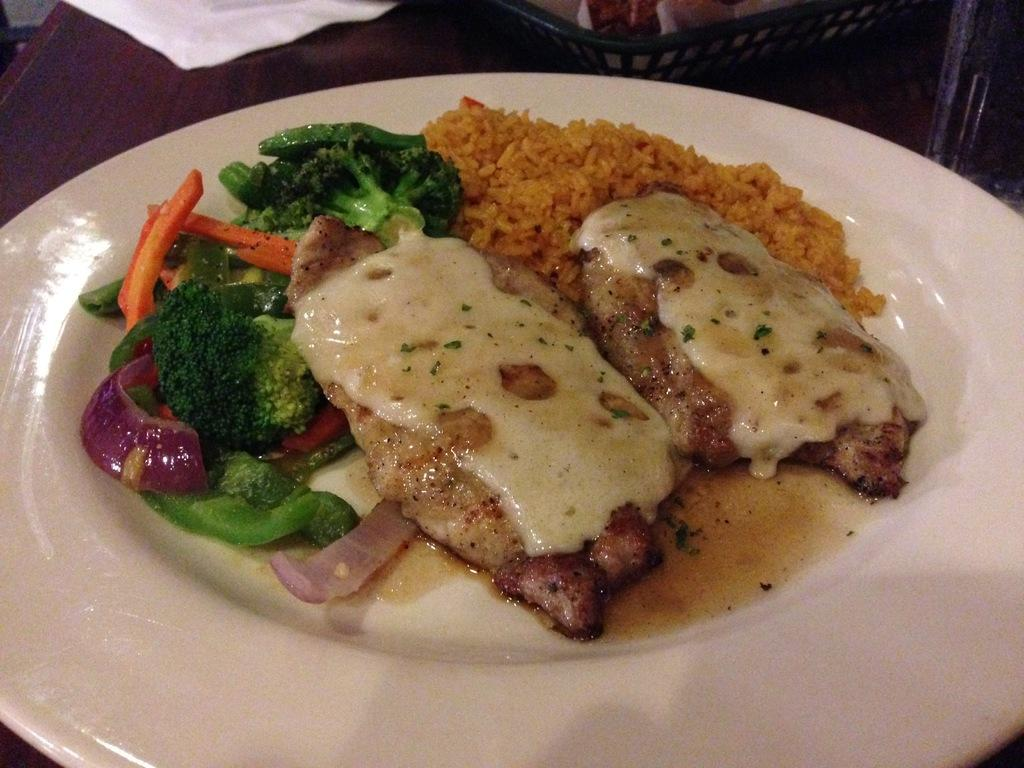What type of food can be seen in the image? The image contains food, but the specific type is not mentioned in the facts. What color is the plate that holds the food? The plate is white in color. What else can be seen in the image besides the food and plate? There are objects visible in the image, but their specific nature is not mentioned in the facts. What is the color of the surface on which the plate is placed? The surface is brown in color. What type of calculator is the mother using while sitting on the zebra in the image? There is no calculator, mother, or zebra present in the image. 